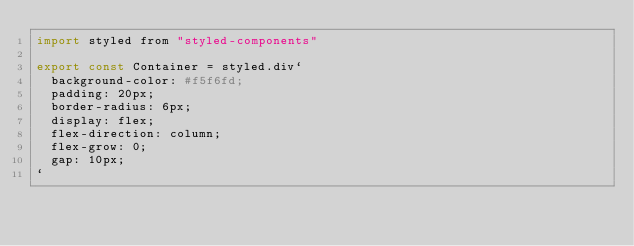Convert code to text. <code><loc_0><loc_0><loc_500><loc_500><_JavaScript_>import styled from "styled-components"

export const Container = styled.div`
  background-color: #f5f6fd;
  padding: 20px;
  border-radius: 6px;
  display: flex;
  flex-direction: column;
  flex-grow: 0;
  gap: 10px;
`
</code> 